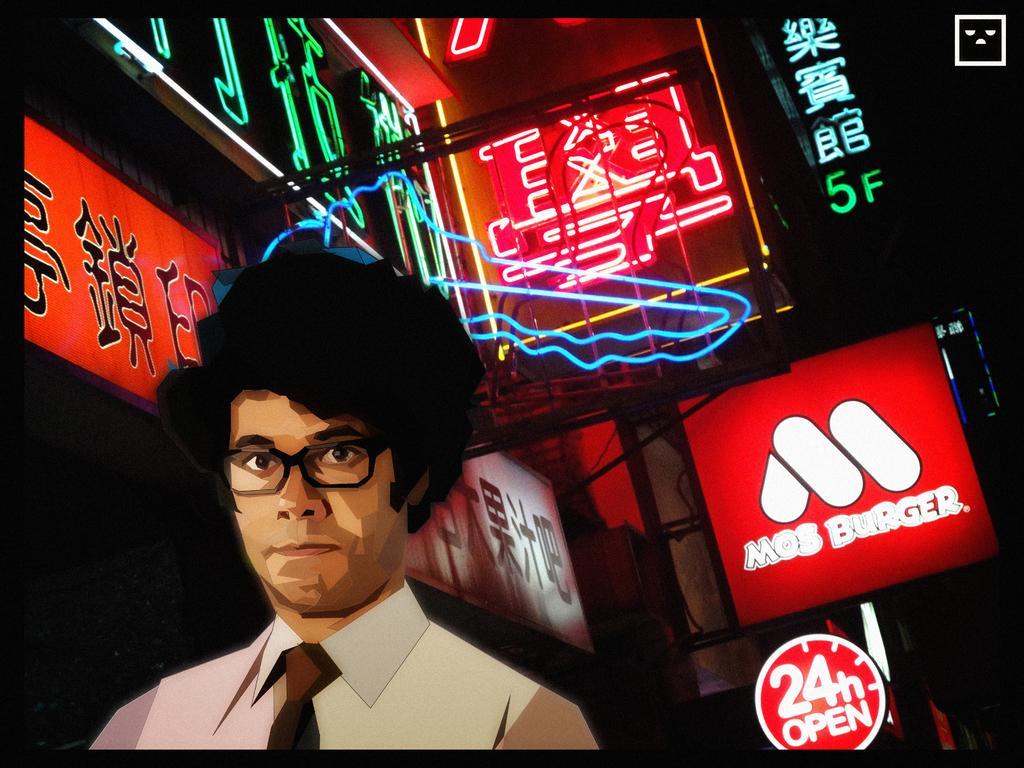Please provide a concise description of this image. This is an animated image. On the left side, there is a person in a white color shirt, wearing a spectacle and watching something. In the background, there are hoardings attached to the walls of the buildings. And the background is dark in color. 